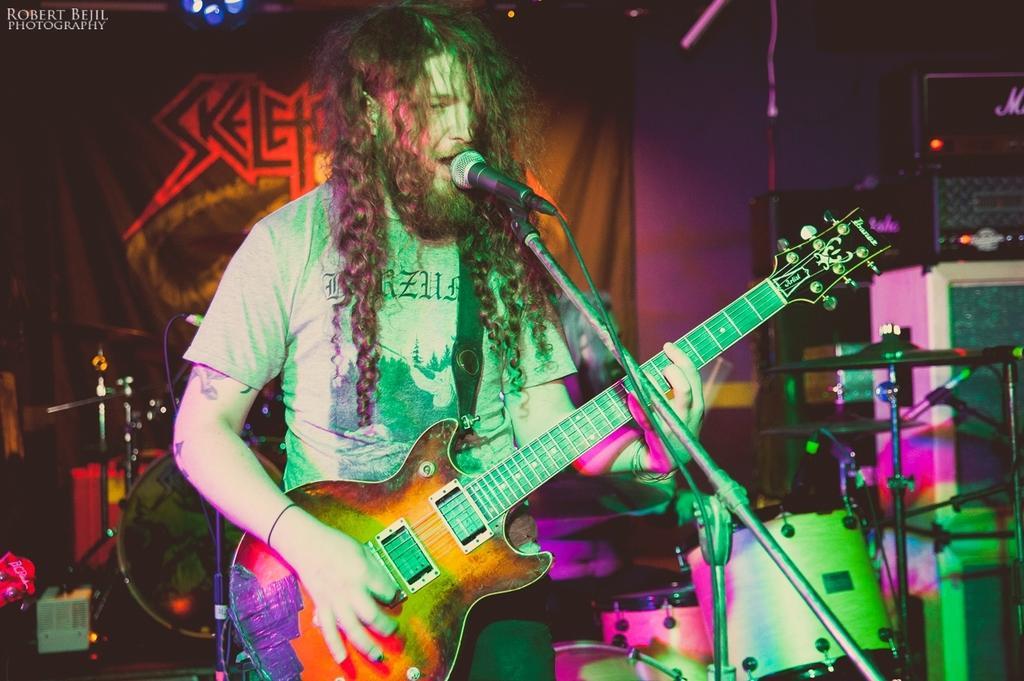How would you summarize this image in a sentence or two? There is a man with grey t-shirt is standing and playing a guitar. In front of him there is a mic. In the background there are musical instruments and on the top there is a poster. 